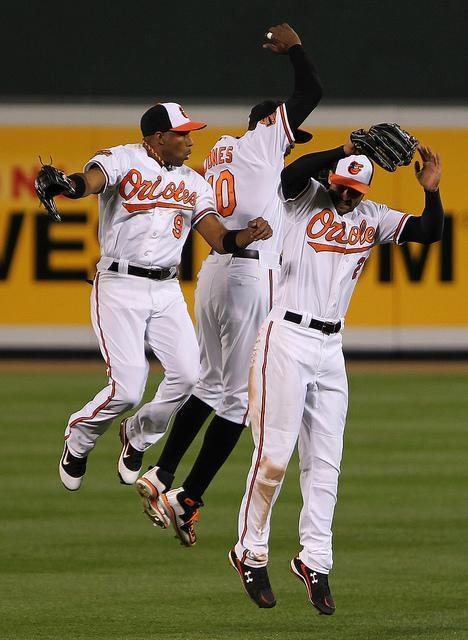How many feet are on the ground?
Give a very brief answer. 0. How many people can you see?
Give a very brief answer. 3. 